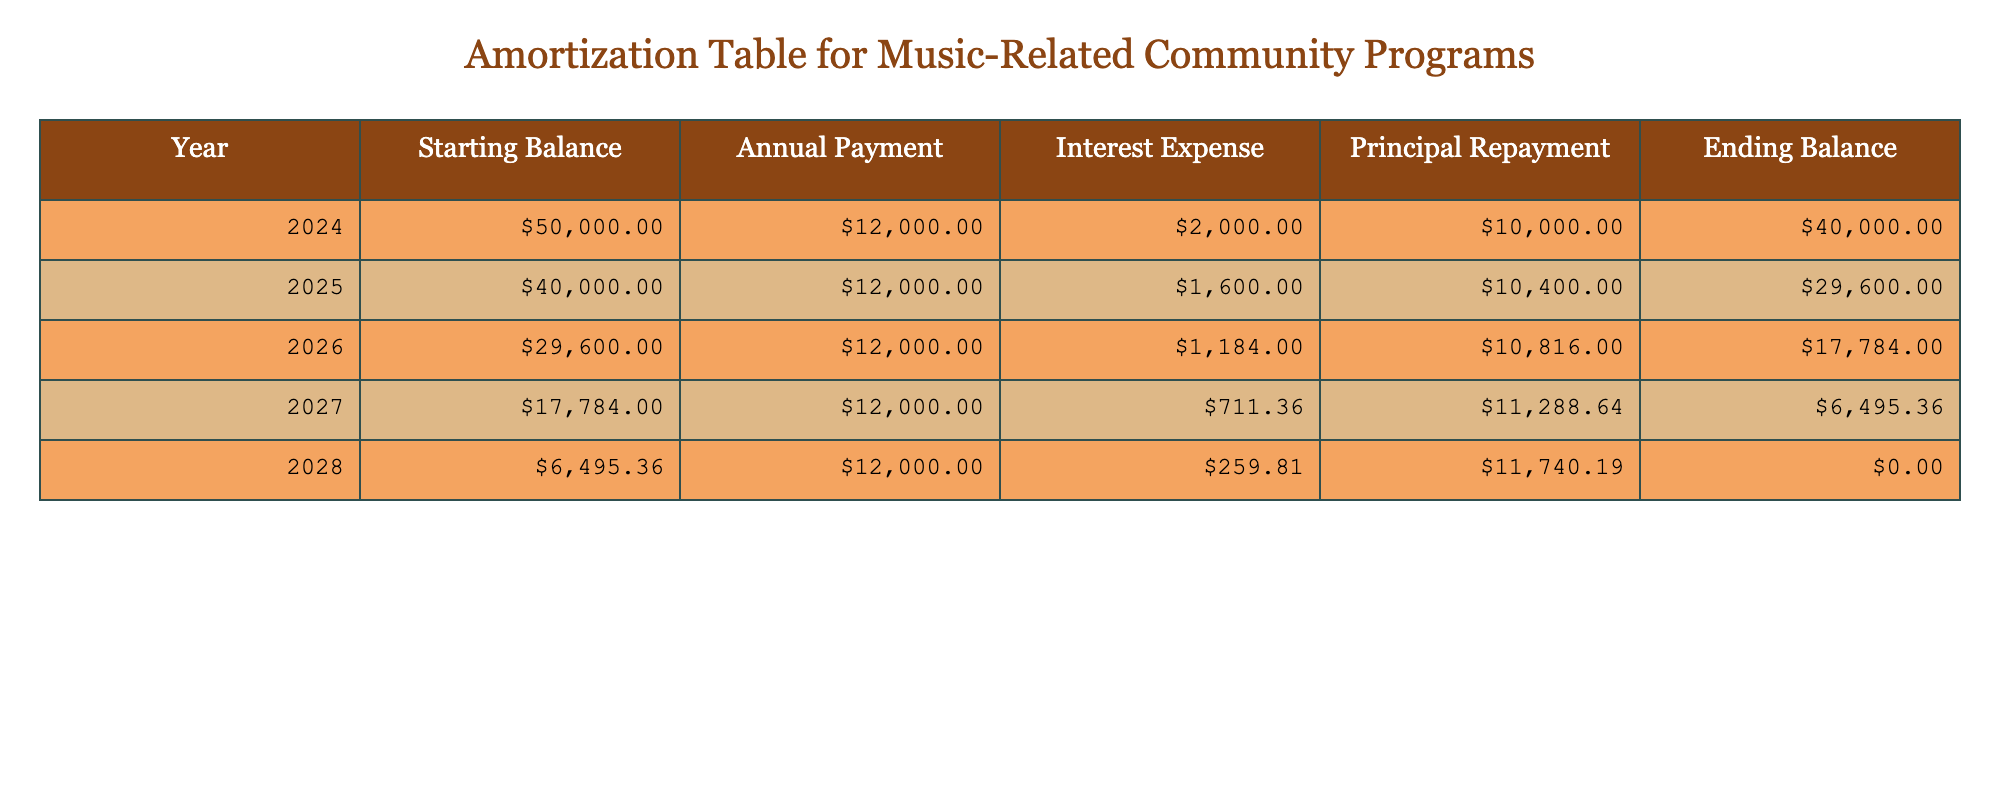What was the ending balance for the year 2026? To find the ending balance for 2026, look at the row for that year in the table and locate the 'Ending Balance' column. The value listed is 17,784.
Answer: 17,784 How much was the total principal repayment over the entire amortization period? Summing the 'Principal Repayment' values from each year gives: 10,000 (2024) + 10,400 (2025) + 10,816 (2026) + 11,288.64 (2027) + 11,740.1856 (2028) = 54,245.8256, which rounds to 54,246.
Answer: 54,246 Did the annual payment change in any of the years? The 'Annual Payment' column shows a constant value of 12,000 across all years; therefore, the answer is no.
Answer: No What was the interest expense for the year 2024? The 'Interest Expense' for 2024 can be directly found in the table, which shows a value of 2,000.
Answer: 2,000 In which year did the annual payment cover the largest proportion of the interest expense? To find this, we compare the ratio of 'Interest Expense' to 'Annual Payment' for each year. The highest ratio is in 2024, where 2,000 (interest) / 12,000 (payment) = 0.1667. Therefore, 2024 covers the largest proportion.
Answer: 2024 What is the average ending balance over the five years? To calculate the average ending balance, sum the 'Ending Balance' values: 40,000 (2024) + 29,600 (2025) + 17,784 (2026) + 6,495.36 (2027) + 0 (2028) = 93,879.36. Then divide by 5, resulting in an average of 18,775.872.
Answer: 18,776 Is there any year where the ending balance was zero? Referring to the 'Ending Balance' column, the value for 2028 is listed as 0, indicating that year had a zero ending balance.
Answer: Yes How much interest was paid in the year 2027 compared to the previous year? In 2027, the 'Interest Expense' was 711.36, and for 2026 it was 1,184. The difference (1,184 - 711.36) is 472.64, meaning 472.64 less interest was paid in 2027 than in 2026.
Answer: 472.64 